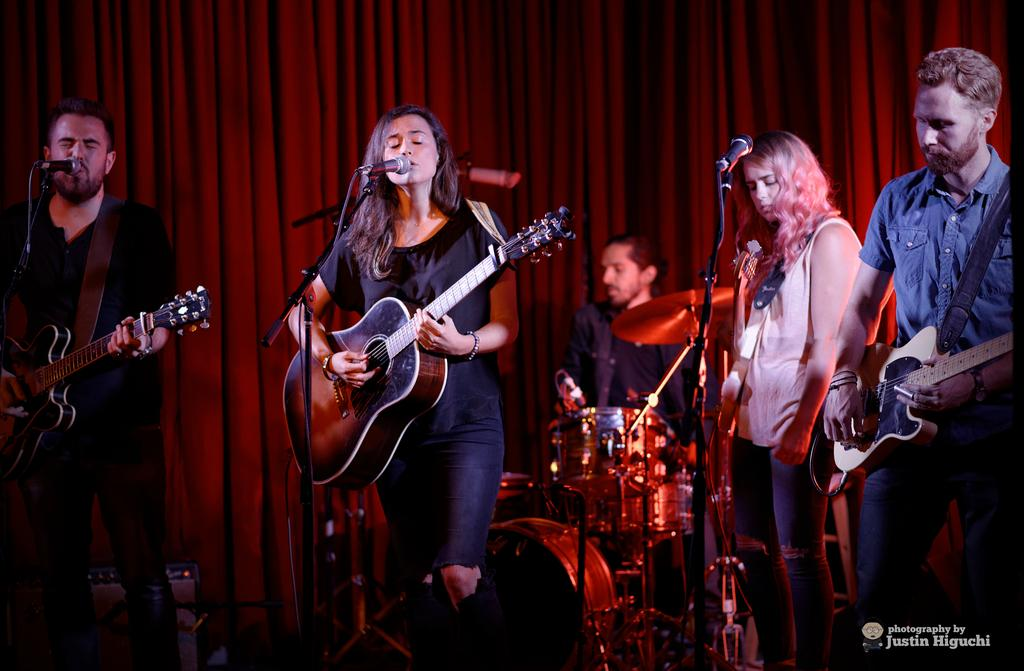How many people are present in the image? There are five people in the image. What can be seen in the background of the image? There is a red color curtain in the background. What are the majority of the people holding in the image? Four of the people are holding guitars. What is the fifth person doing in the image? One person is playing musical drums. How much sugar is present in the image? There is no reference to sugar in the image, so it cannot be determined. What is the distance between the two people holding guitars on the left side of the image? The image does not provide enough information to determine the distance between the two people holding guitars on the left side. 